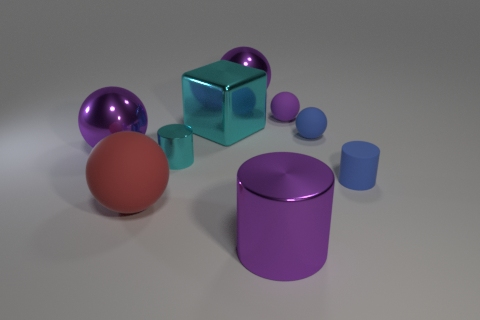There is a ball that is in front of the tiny blue thing that is in front of the tiny metallic object; what is its size?
Ensure brevity in your answer.  Large. The big matte object that is the same shape as the tiny purple matte object is what color?
Provide a short and direct response. Red. Is the size of the red object the same as the blue sphere?
Offer a terse response. No. Are there an equal number of cyan shiny objects on the left side of the block and big red objects?
Offer a very short reply. Yes. There is a cyan object that is behind the cyan cylinder; are there any big balls to the right of it?
Make the answer very short. Yes. What size is the shiny thing that is to the left of the ball in front of the tiny matte object that is in front of the small cyan metal thing?
Offer a terse response. Large. There is a large block on the right side of the small cylinder that is on the left side of the big cyan block; what is it made of?
Your answer should be very brief. Metal. Is there a large blue object of the same shape as the large cyan metal thing?
Your answer should be compact. No. What is the shape of the big cyan metallic object?
Your answer should be compact. Cube. There is a big purple object in front of the big purple metallic ball that is left of the big rubber thing on the left side of the blue matte ball; what is its material?
Ensure brevity in your answer.  Metal. 